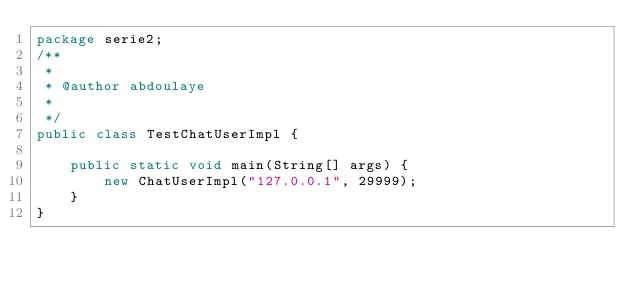<code> <loc_0><loc_0><loc_500><loc_500><_Java_>package serie2;
/**
 * 
 * @author abdoulaye
 *
 */
public class TestChatUserImpl {
	   
    public static void main(String[] args) {
        new ChatUserImpl("127.0.0.1", 29999);
    }
}
</code> 